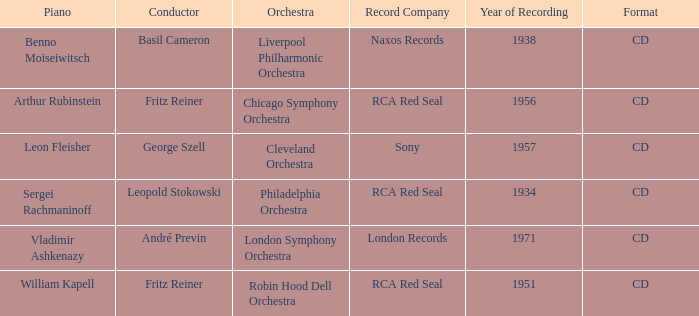Which orchestra has a recording year of 1951? Robin Hood Dell Orchestra. 